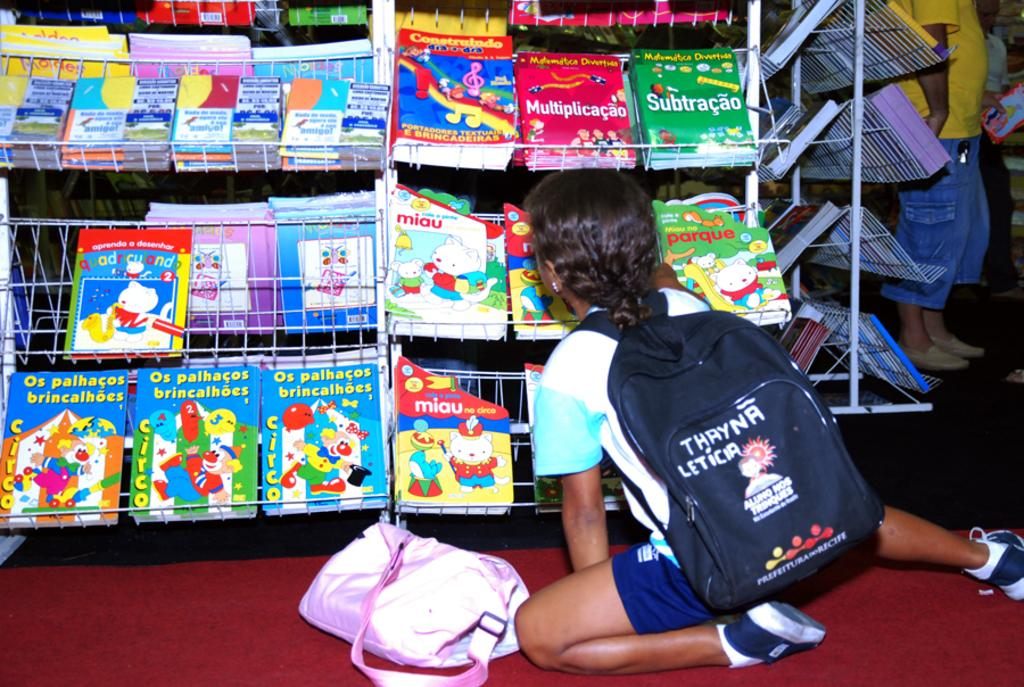<image>
Share a concise interpretation of the image provided. Person wearing a black backpack that says Thayna Leticia on it. 